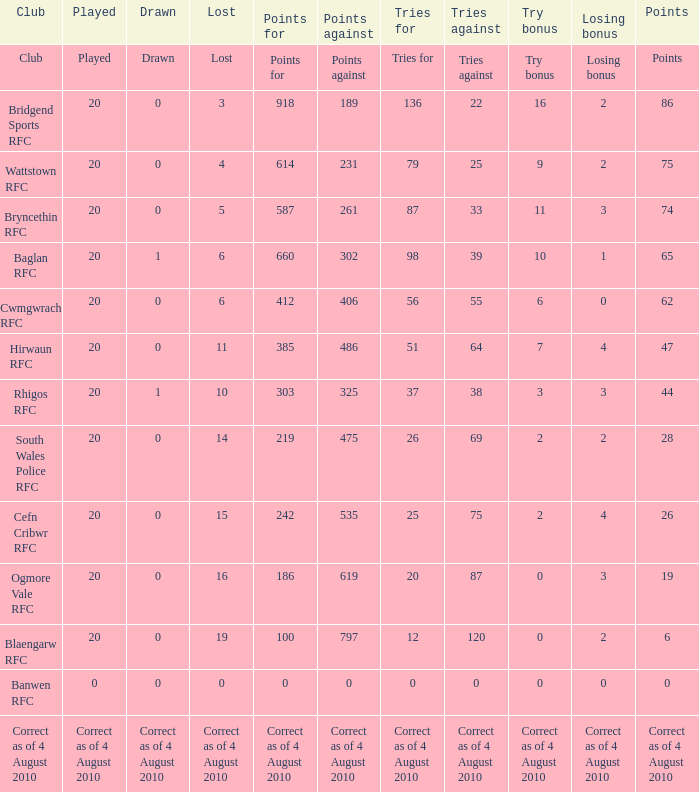What is the attempts for when forfeiting bonus is relinquishing bonus? Tries for. 